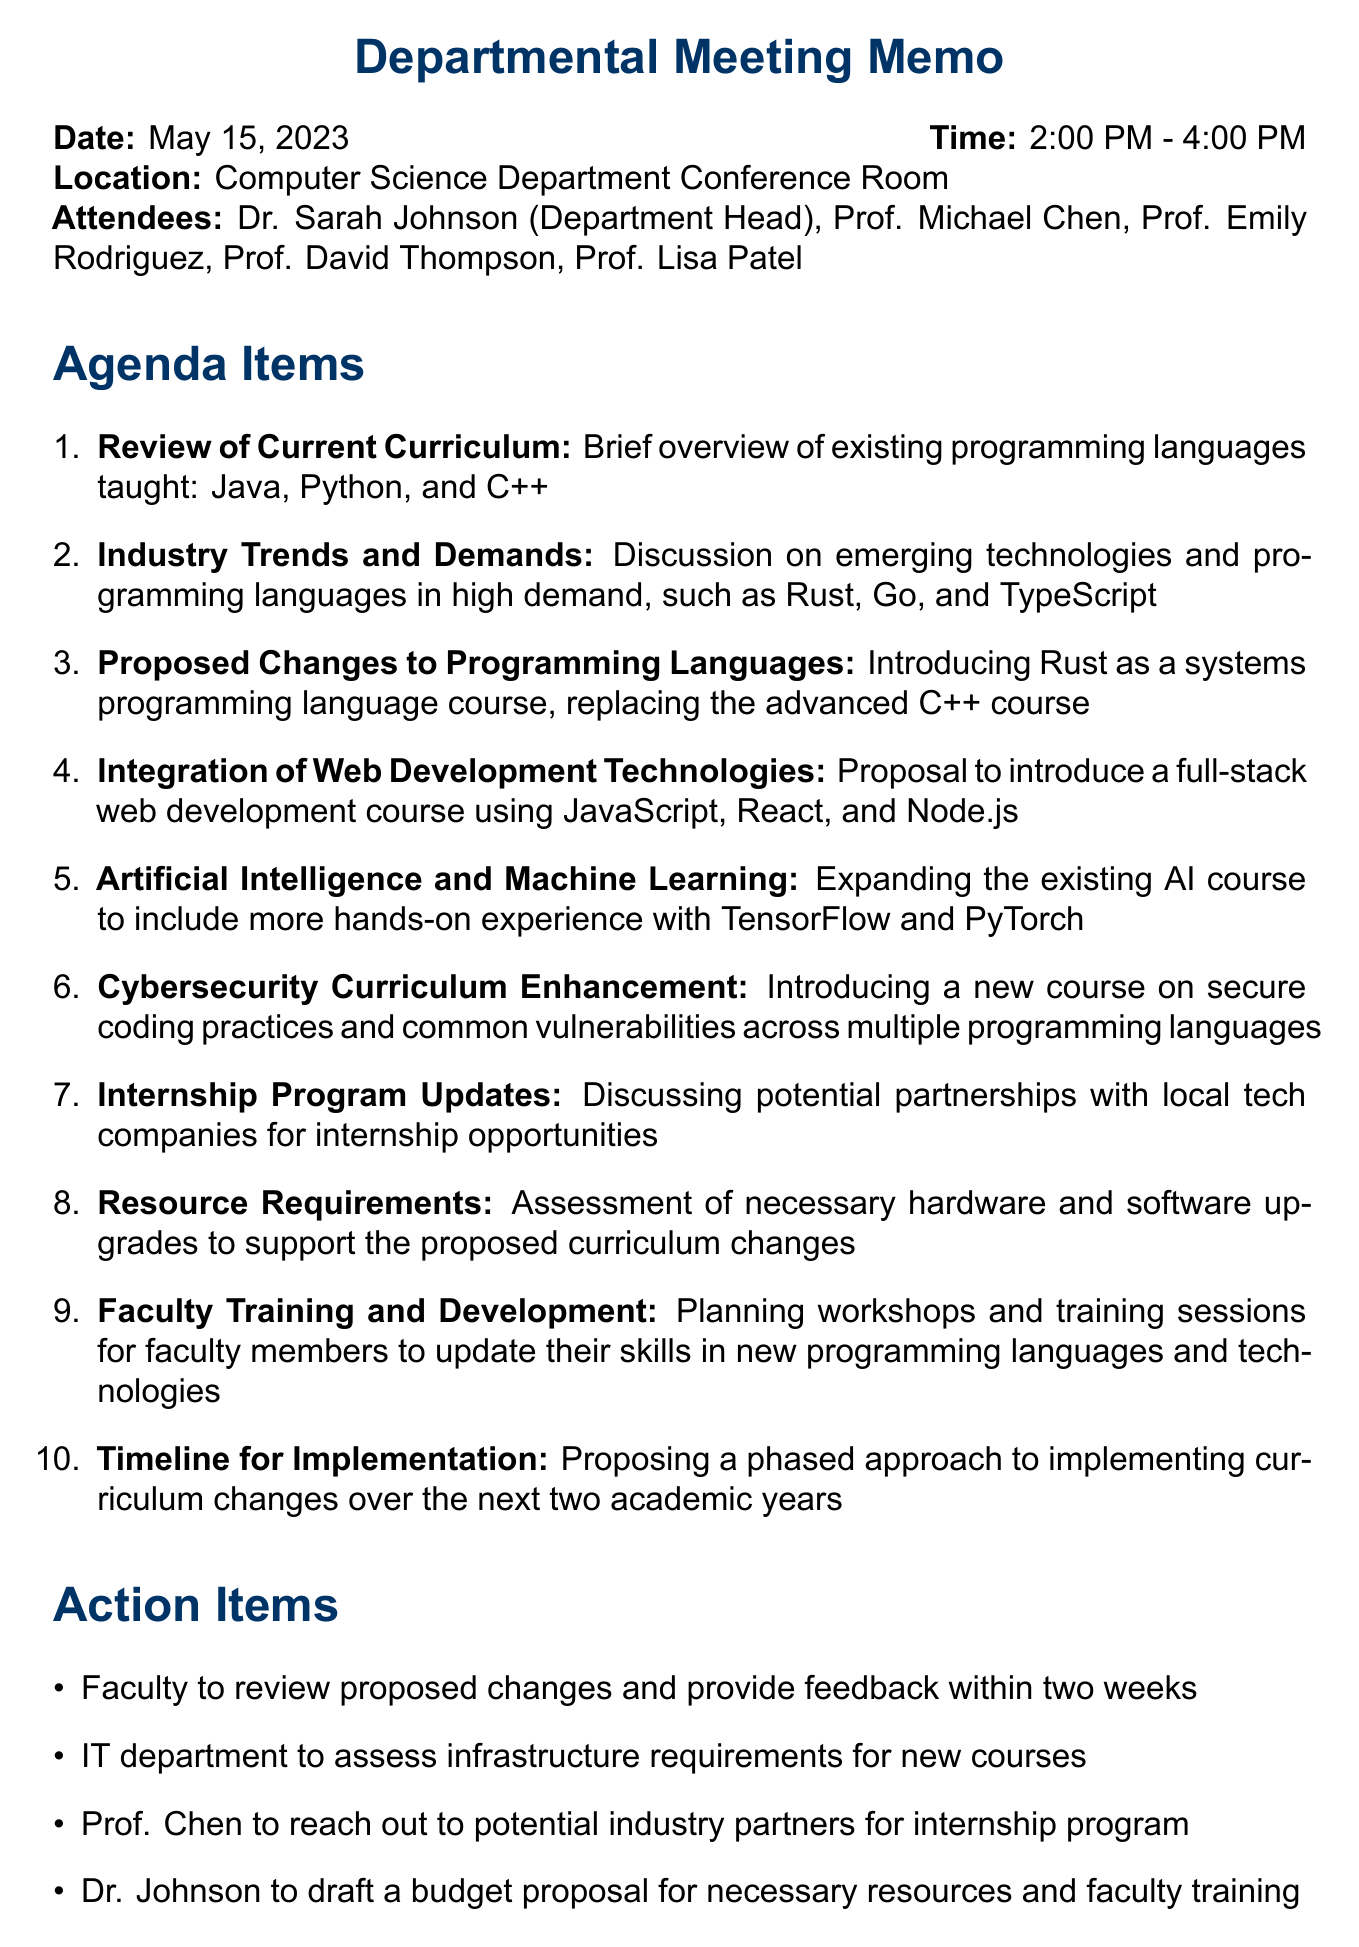What is the date of the meeting? The date is explicitly mentioned in the document, which states it is May 15, 2023.
Answer: May 15, 2023 Who is the department head? The document lists Dr. Sarah Johnson as the Department Head among the attendees.
Answer: Dr. Sarah Johnson What programming languages are currently taught? A brief overview of existing programming languages is provided, specifically mentioning Java, Python, and C++.
Answer: Java, Python, and C++ What new programming language is proposed to be introduced? The agenda includes a proposal to introduce Rust as a systems programming language course.
Answer: Rust What is the rationale for replacing the advanced C++ course? The document states that Rust's growing popularity in systems programming and its focus on memory safety and concurrency is the rationale.
Answer: Rust's growing popularity What is one of the proposed technologies for web development courses? The proposal mentions using JavaScript, React, and Node.js in the full-stack web development course.
Answer: JavaScript How long is the proposed timeline for implementation of the curriculum changes? The document proposes a phased approach to implementing the changes over the next two academic years.
Answer: Two academic years What action is Prof. Chen responsible for? The action items indicate that Prof. Chen is to reach out to potential industry partners for the internship program.
Answer: Reach out to potential industry partners What is one of the topics of discussion related to AI? The agenda states an expansion of the existing AI course to include more hands-on experience with TensorFlow and PyTorch.
Answer: TensorFlow and PyTorch 